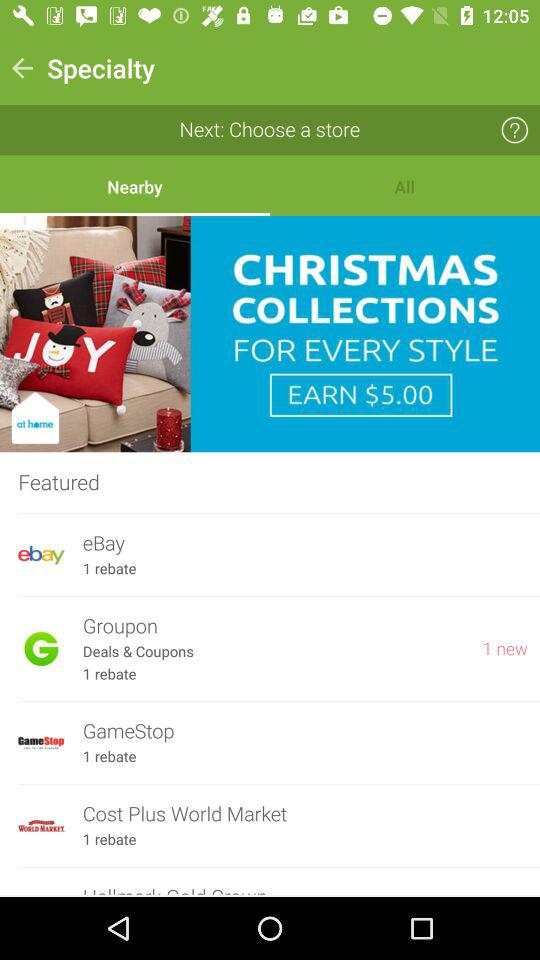How many rebates are there at GameStop? There is 1 rebate. 